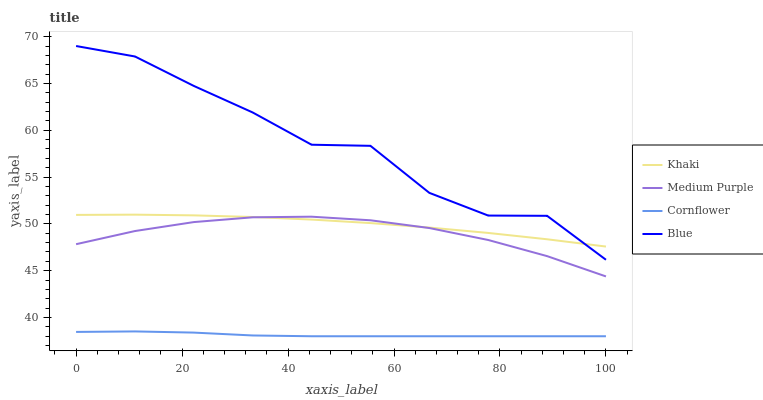Does Khaki have the minimum area under the curve?
Answer yes or no. No. Does Khaki have the maximum area under the curve?
Answer yes or no. No. Is Khaki the smoothest?
Answer yes or no. No. Is Khaki the roughest?
Answer yes or no. No. Does Khaki have the lowest value?
Answer yes or no. No. Does Khaki have the highest value?
Answer yes or no. No. Is Medium Purple less than Blue?
Answer yes or no. Yes. Is Medium Purple greater than Cornflower?
Answer yes or no. Yes. Does Medium Purple intersect Blue?
Answer yes or no. No. 